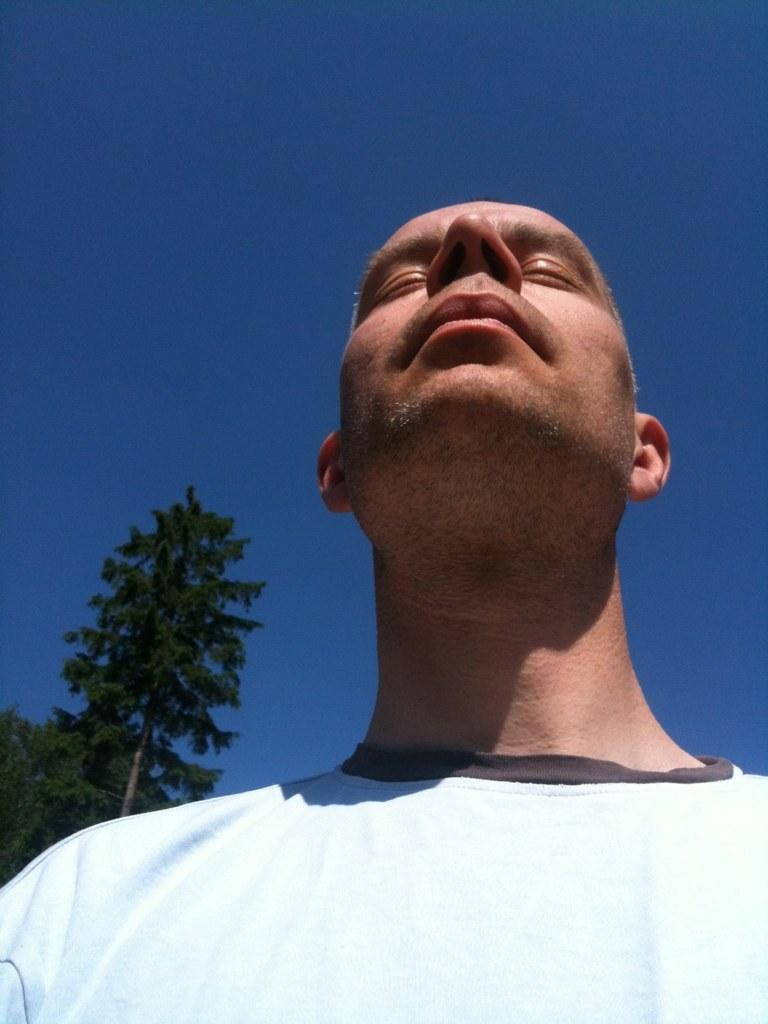Who is present in the image? There is a man in the image. What is the man wearing? The man is wearing a white t-shirt. What can be seen in the background of the image? There are trees in the background of the image. What is visible at the top of the image? The sky is visible at the top of the image. What type of receipt can be seen in the man's hand in the image? There is no receipt present in the man's hand or anywhere in the image. What kind of waste is visible on the ground in the image? There is no waste visible on the ground or anywhere in the image. 